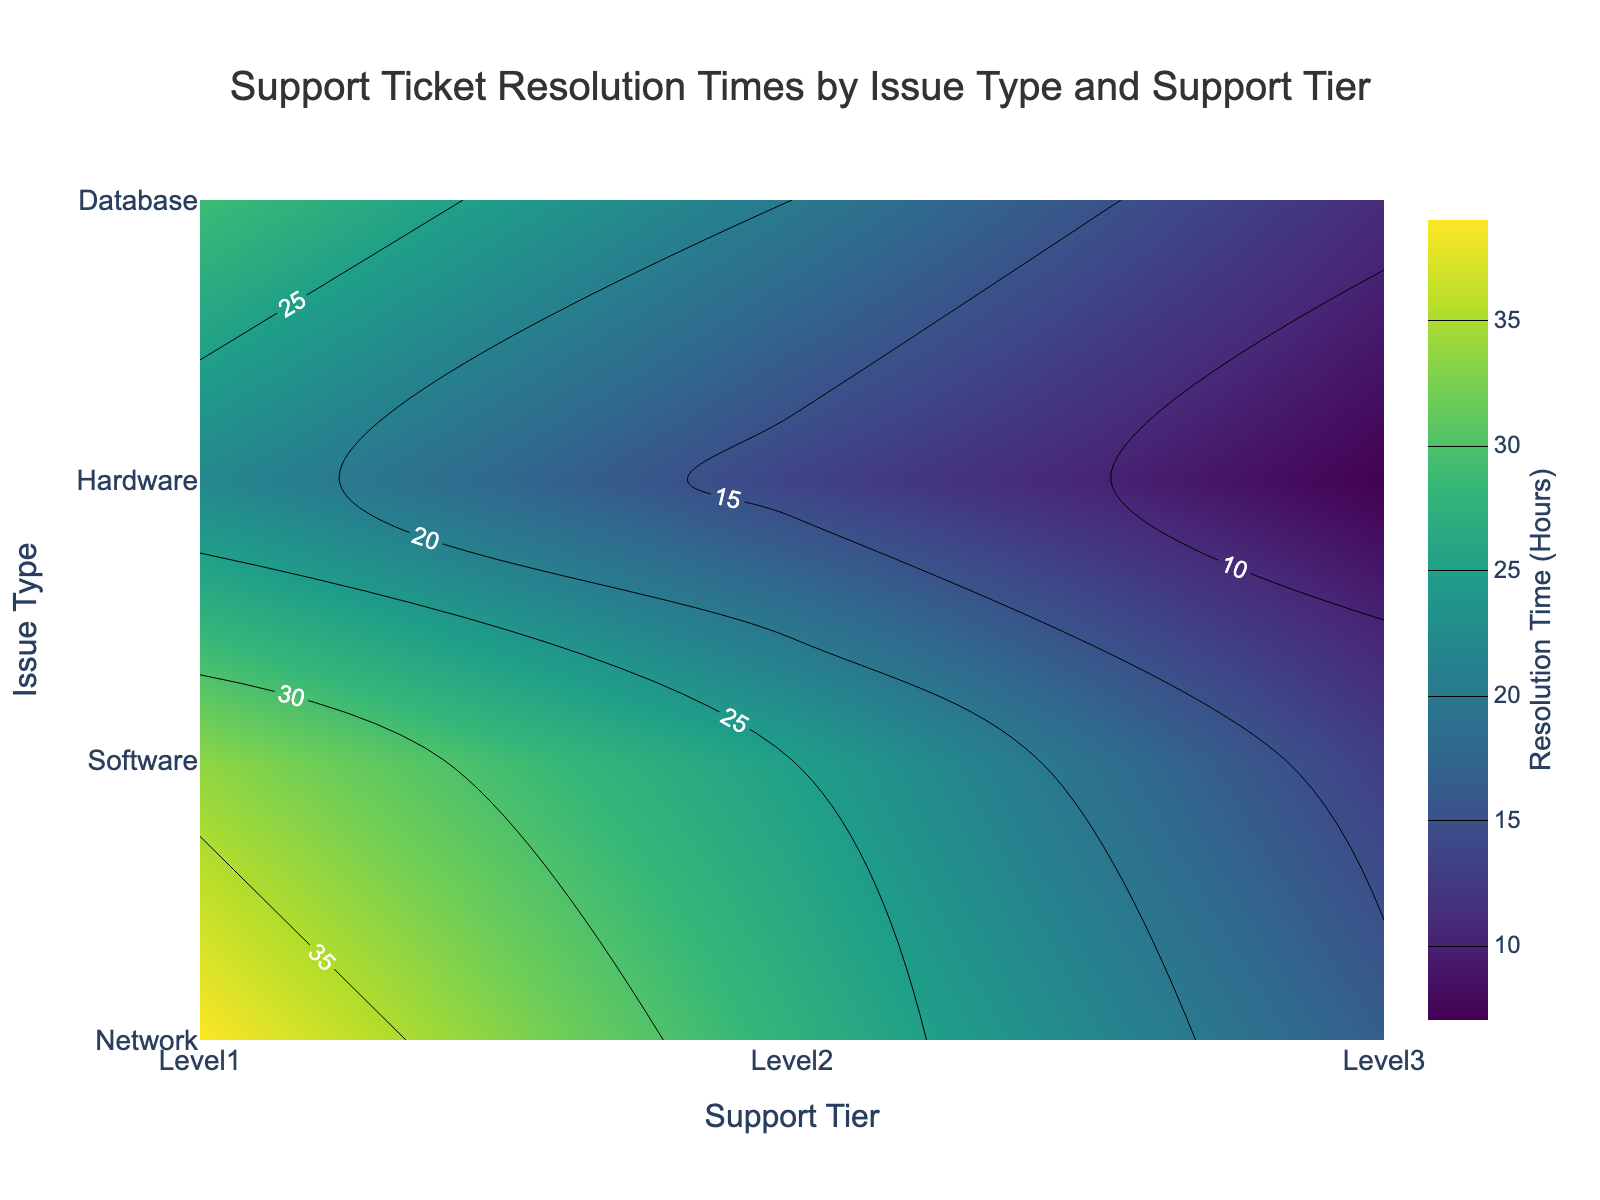How many different support tiers are displayed in the figure? There are three different support tiers labeled on the x-axis. These are Level1, Level2, and Level3.
Answer: 3 What is the title of the figure? The title is located at the top center of the figure and reads "Support Ticket Resolution Times by Issue Type and Support Tier."
Answer: Support Ticket Resolution Times by Issue Type and Support Tier Which support tier typically has the longest resolution times? The y-axis represents different issue types and the x-axis represents support tiers. By looking at the contour values, Level1 support tier generally shows the highest resolution times across all issue types.
Answer: Level1 Does the "Hardware" issue type have a lower average resolution time at Level3 or Level2? For "Hardware", check the resolution times at both Level2 and Level3. Level2 has average resolution times of 26 and 24 hours, while Level3 has 14 and 12 hours. Therefore, Level3 has a lower average resolution time for Hardware issues.
Answer: Level3 What's the color scale used in the figure to represent resolution times? The color scale used in this figure is 'Viridis', which ranges from dark blue to yellow. Darker colors represent shorter resolution times and lighter colors represent longer resolution times.
Answer: Viridis Which issue type has the shortest resolution time at the highest support level? To find this, look at the last column for the highest support tier (Level3). Among all issue types, "Network" has the shortest resolution times (8 and 6 hours) within Level3.
Answer: Network If I have a "Database" issue, which support tier should I aim for quicker resolution? By checking the "Database" row, Level3 support tier has significantly lower resolution times (18 and 15 hours) compared to Level1 and Level2 tiers.
Answer: Level3 Which issue type has the most consistent resolution times across different support tiers? Look at the contour lines across different tiers for each issue type. "Software" shows relatively smaller variation in resolution times ranging from 30 at Level1 to 10 at Level3.
Answer: Software What is the average resolution time for "Software" issues at Level2? The average resolution time can be calculated by taking the mean of the resolution times for "Software" at Level2, which are (22 + 18)/2 = 20 hours.
Answer: 20 